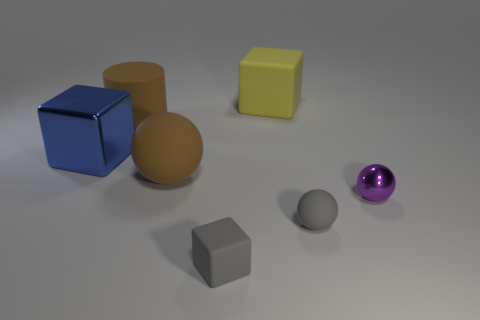Add 3 yellow balls. How many objects exist? 10 Subtract all cubes. How many objects are left? 4 Add 5 brown cylinders. How many brown cylinders exist? 6 Subtract 1 brown balls. How many objects are left? 6 Subtract all large gray blocks. Subtract all large blocks. How many objects are left? 5 Add 4 big blue metallic objects. How many big blue metallic objects are left? 5 